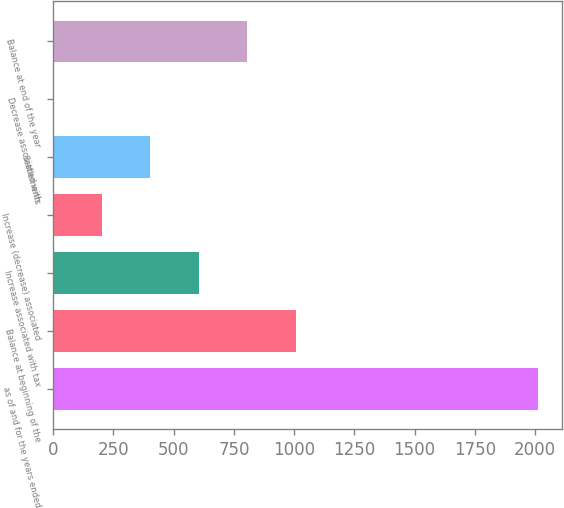Convert chart to OTSL. <chart><loc_0><loc_0><loc_500><loc_500><bar_chart><fcel>as of and for the years ended<fcel>Balance at beginning of the<fcel>Increase associated with tax<fcel>Increase (decrease) associated<fcel>Settlements<fcel>Decrease associated with<fcel>Balance at end of the year<nl><fcel>2012<fcel>1006.5<fcel>604.3<fcel>202.1<fcel>403.2<fcel>1<fcel>805.4<nl></chart> 